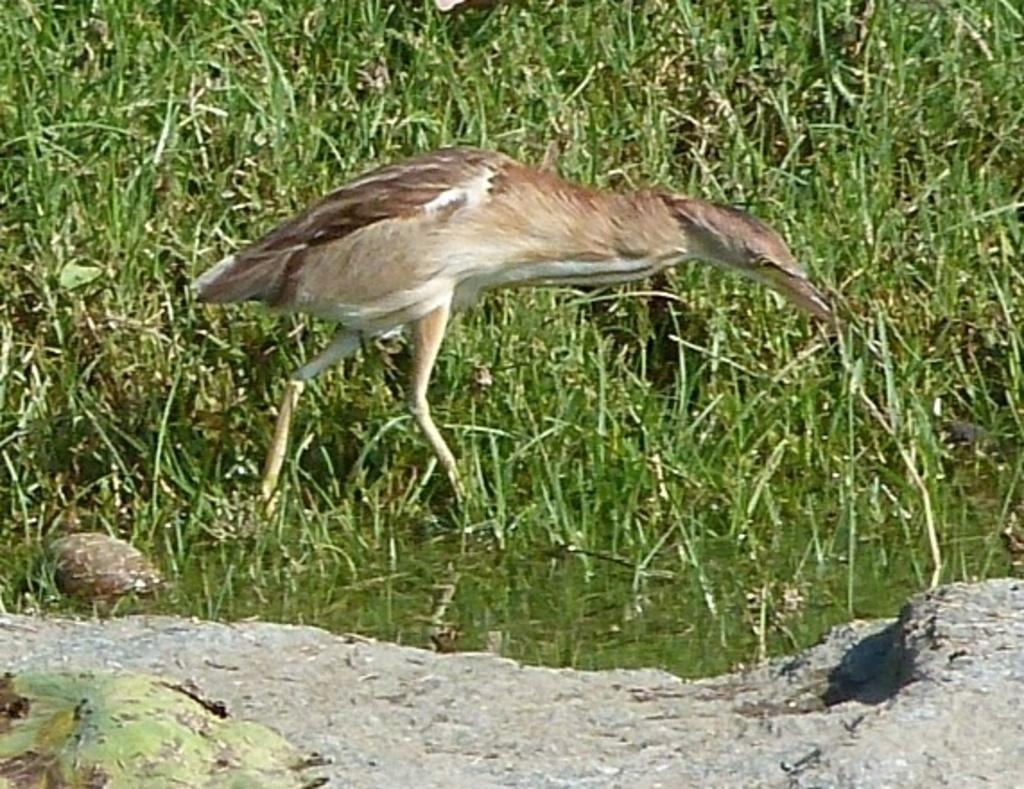What type of animal can be seen in the water in the image? There is a bird in the water in the image. What type of vegetation is visible in the image? There is grass visible in the image. What other object can be seen in the image besides the bird and grass? There is a rock in the image. How many engines are visible in the image? There are no engines present in the image. Can you describe the cats in the image? There are no cats present in the image. 